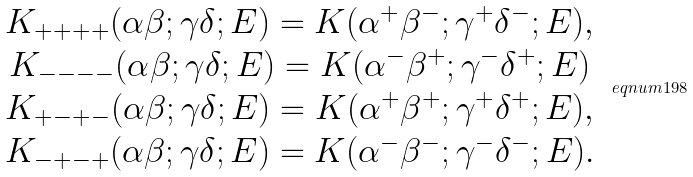<formula> <loc_0><loc_0><loc_500><loc_500>\begin{array} { c } K _ { + + + + } ( \alpha \beta ; \gamma \delta ; E ) = K ( \alpha ^ { + } \beta ^ { - } ; \gamma ^ { + } \delta ^ { - } ; E ) , \\ K _ { - - - - } ( \alpha \beta ; \gamma \delta ; E ) = K ( \alpha ^ { - } \beta ^ { + } ; \gamma ^ { - } \delta ^ { + } ; E ) \\ K _ { + - + - } ( \alpha \beta ; \gamma \delta ; E ) = K ( \alpha ^ { + } \beta ^ { + } ; \gamma ^ { + } \delta ^ { + } ; E ) , \\ K _ { - + - + } ( \alpha \beta ; \gamma \delta ; E ) = K ( \alpha ^ { - } \beta ^ { - } ; \gamma ^ { - } \delta ^ { - } ; E ) . \end{array} \ e q n u m { 1 9 8 }</formula> 